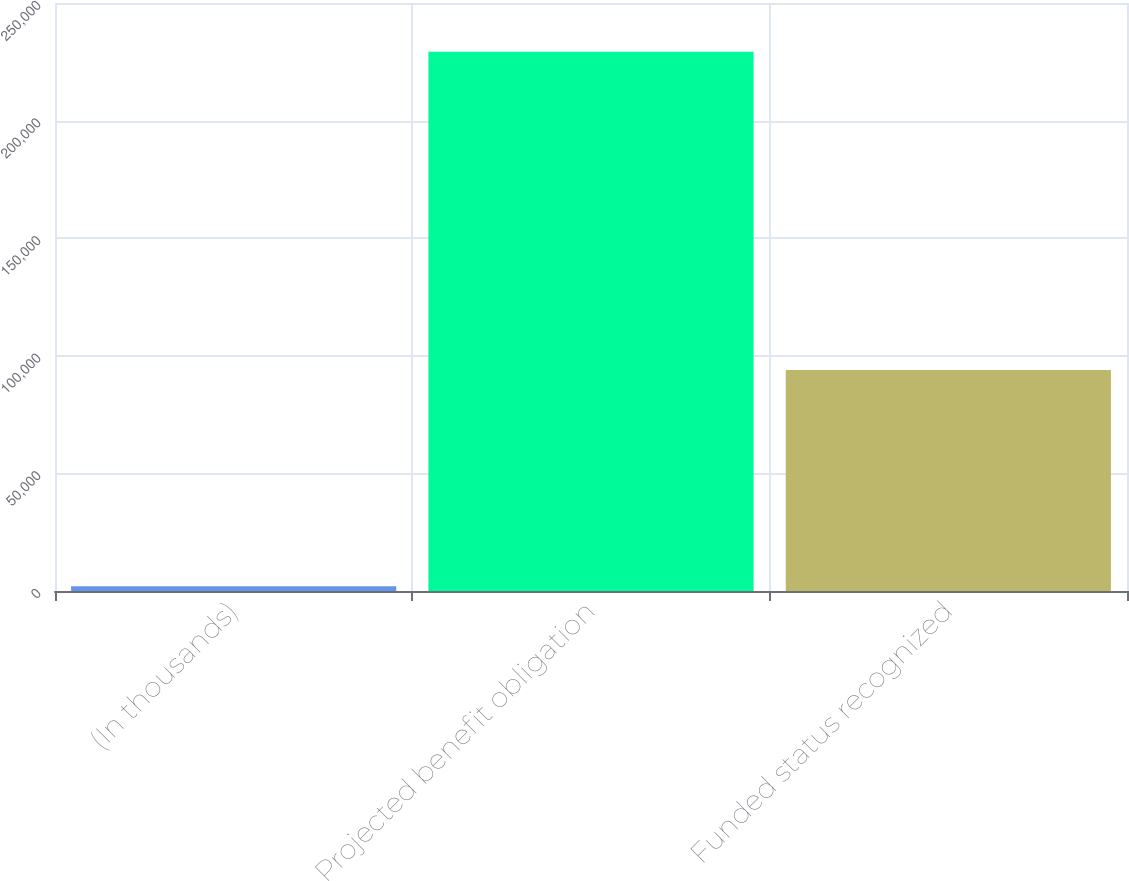<chart> <loc_0><loc_0><loc_500><loc_500><bar_chart><fcel>(In thousands)<fcel>Projected benefit obligation<fcel>Funded status recognized<nl><fcel>2015<fcel>229241<fcel>93992<nl></chart> 